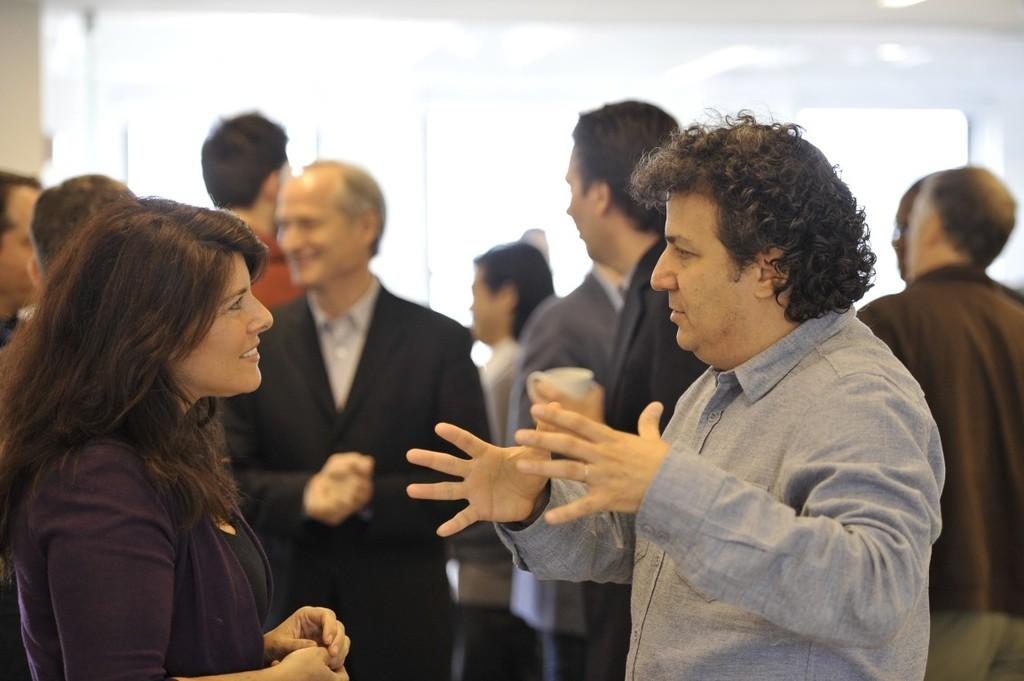How many people are in the image? There is a group of persons in the image, but the exact number is not specified. What can be seen in the background of the image? There is a wall in the image. What type of bubble is floating near the group of persons in the image? There is no bubble present in the image. Where is the library located in the image? There is no library present in the image. 